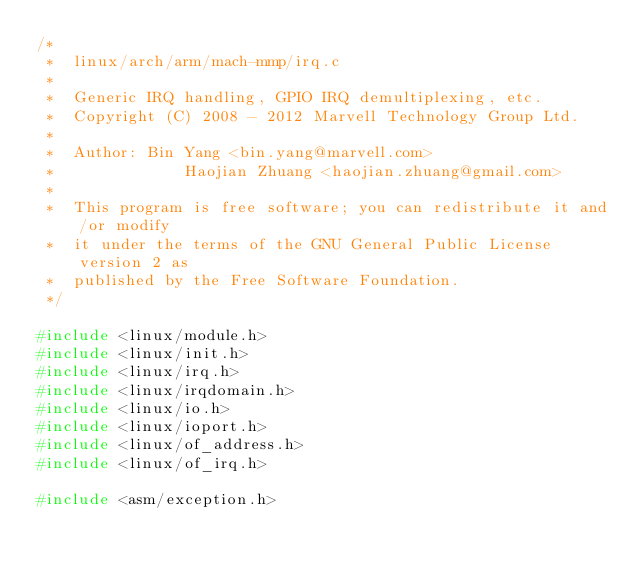<code> <loc_0><loc_0><loc_500><loc_500><_C_>/*
 *  linux/arch/arm/mach-mmp/irq.c
 *
 *  Generic IRQ handling, GPIO IRQ demultiplexing, etc.
 *  Copyright (C) 2008 - 2012 Marvell Technology Group Ltd.
 *
 *  Author:	Bin Yang <bin.yang@marvell.com>
 *              Haojian Zhuang <haojian.zhuang@gmail.com>
 *
 *  This program is free software; you can redistribute it and/or modify
 *  it under the terms of the GNU General Public License version 2 as
 *  published by the Free Software Foundation.
 */

#include <linux/module.h>
#include <linux/init.h>
#include <linux/irq.h>
#include <linux/irqdomain.h>
#include <linux/io.h>
#include <linux/ioport.h>
#include <linux/of_address.h>
#include <linux/of_irq.h>

#include <asm/exception.h></code> 